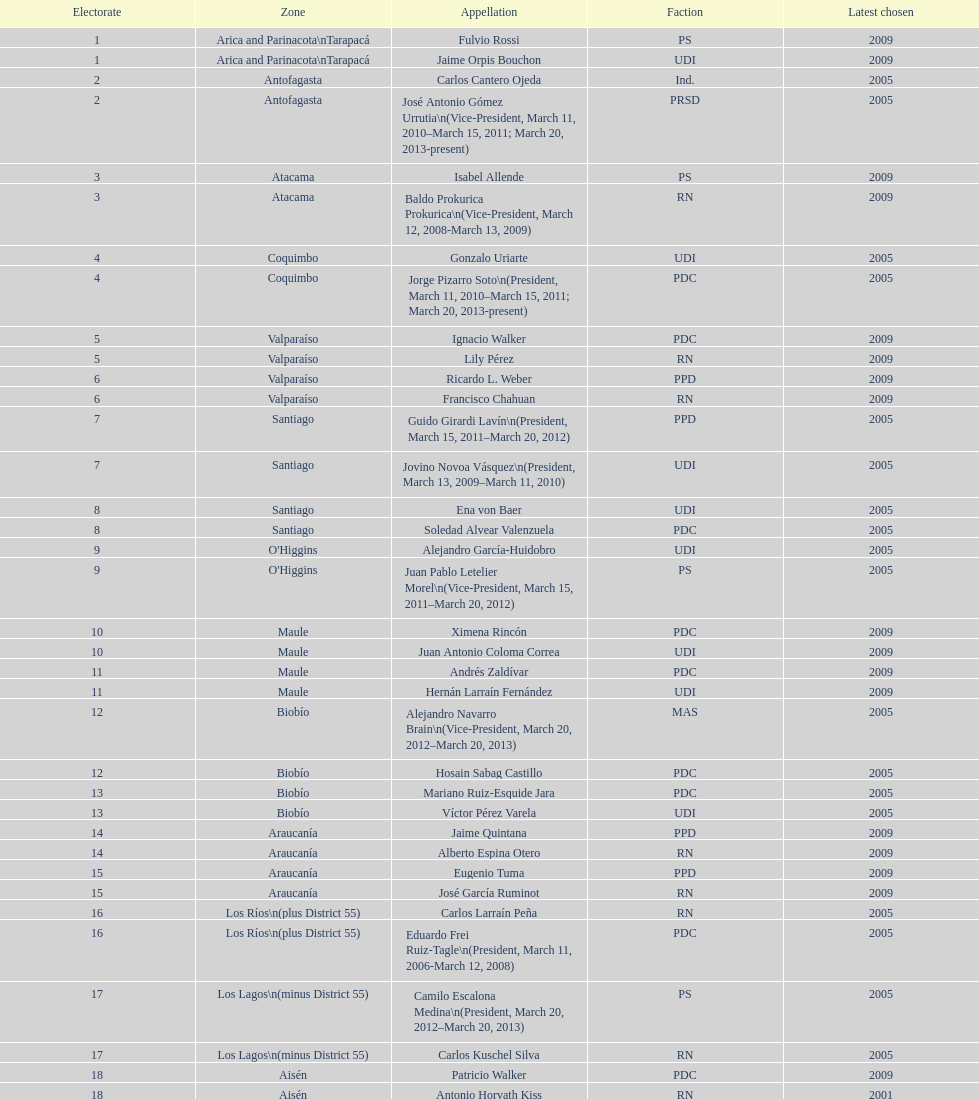What is the difference in years between constiuency 1 and 2? 4 years. 